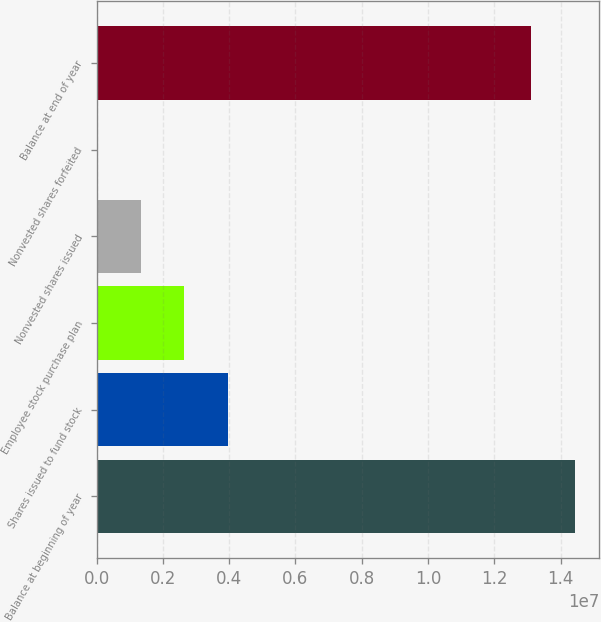Convert chart. <chart><loc_0><loc_0><loc_500><loc_500><bar_chart><fcel>Balance at beginning of year<fcel>Shares issued to fund stock<fcel>Employee stock purchase plan<fcel>Nonvested shares issued<fcel>Nonvested shares forfeited<fcel>Balance at end of year<nl><fcel>1.44446e+07<fcel>3.96936e+06<fcel>2.64772e+06<fcel>1.32609e+06<fcel>4447<fcel>1.3123e+07<nl></chart> 